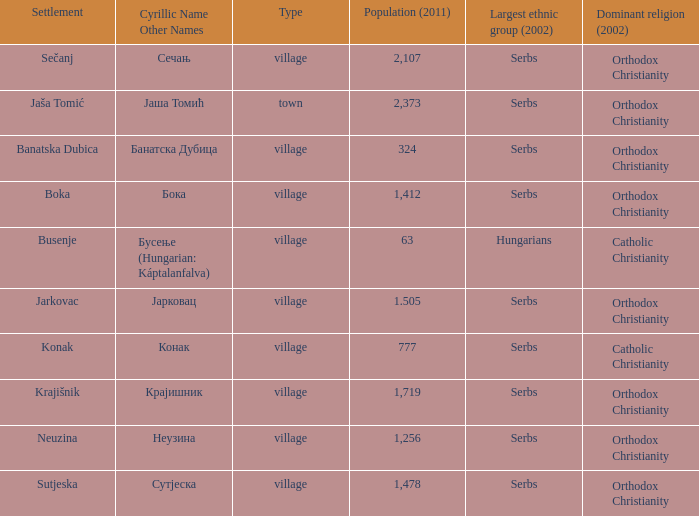What town has the population of 777? Конак. 